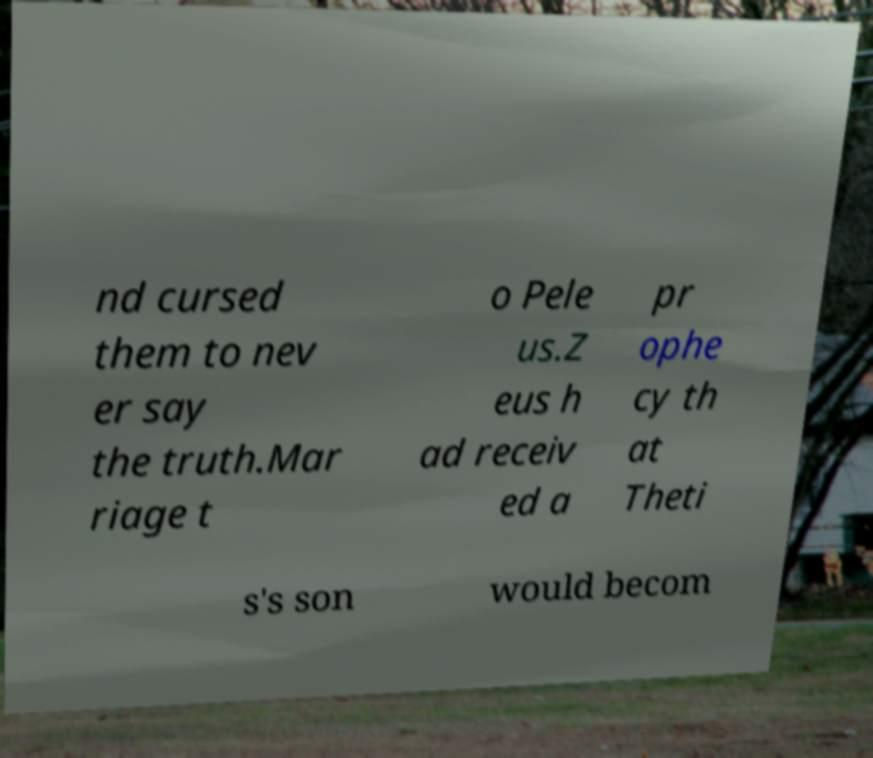There's text embedded in this image that I need extracted. Can you transcribe it verbatim? nd cursed them to nev er say the truth.Mar riage t o Pele us.Z eus h ad receiv ed a pr ophe cy th at Theti s's son would becom 